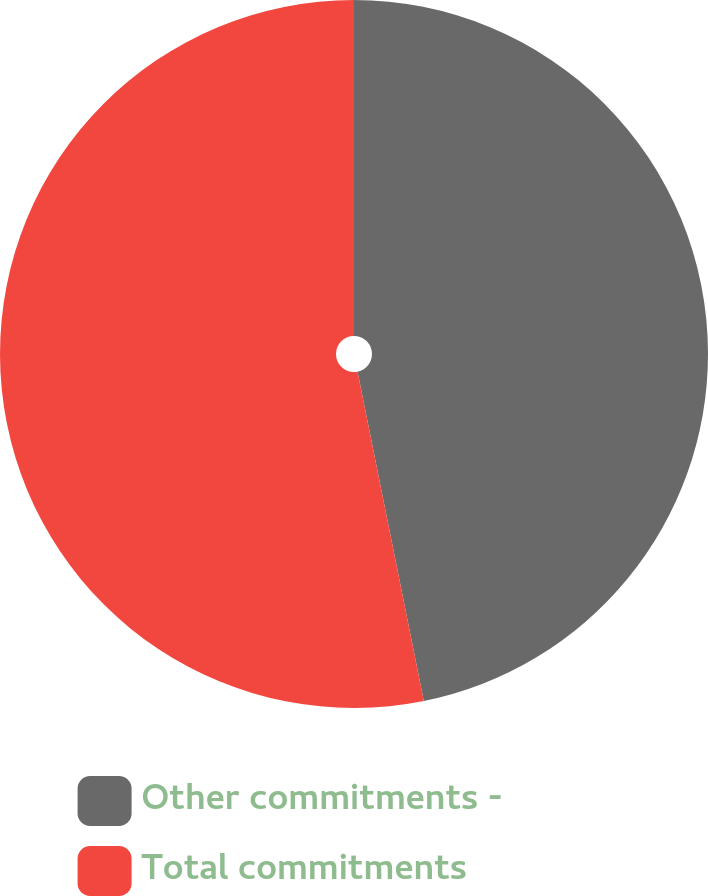Convert chart. <chart><loc_0><loc_0><loc_500><loc_500><pie_chart><fcel>Other commitments -<fcel>Total commitments<nl><fcel>46.84%<fcel>53.16%<nl></chart> 